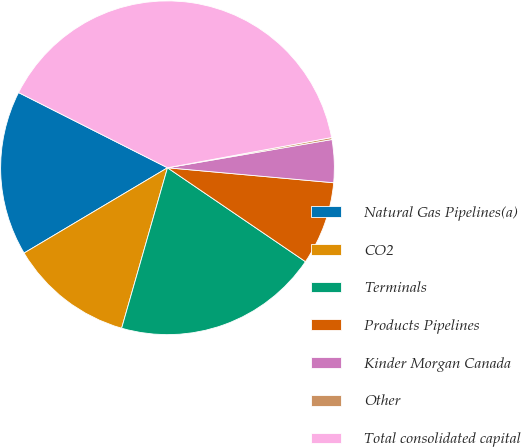Convert chart to OTSL. <chart><loc_0><loc_0><loc_500><loc_500><pie_chart><fcel>Natural Gas Pipelines(a)<fcel>CO2<fcel>Terminals<fcel>Products Pipelines<fcel>Kinder Morgan Canada<fcel>Other<fcel>Total consolidated capital<nl><fcel>15.98%<fcel>12.03%<fcel>19.92%<fcel>8.08%<fcel>4.14%<fcel>0.19%<fcel>39.66%<nl></chart> 